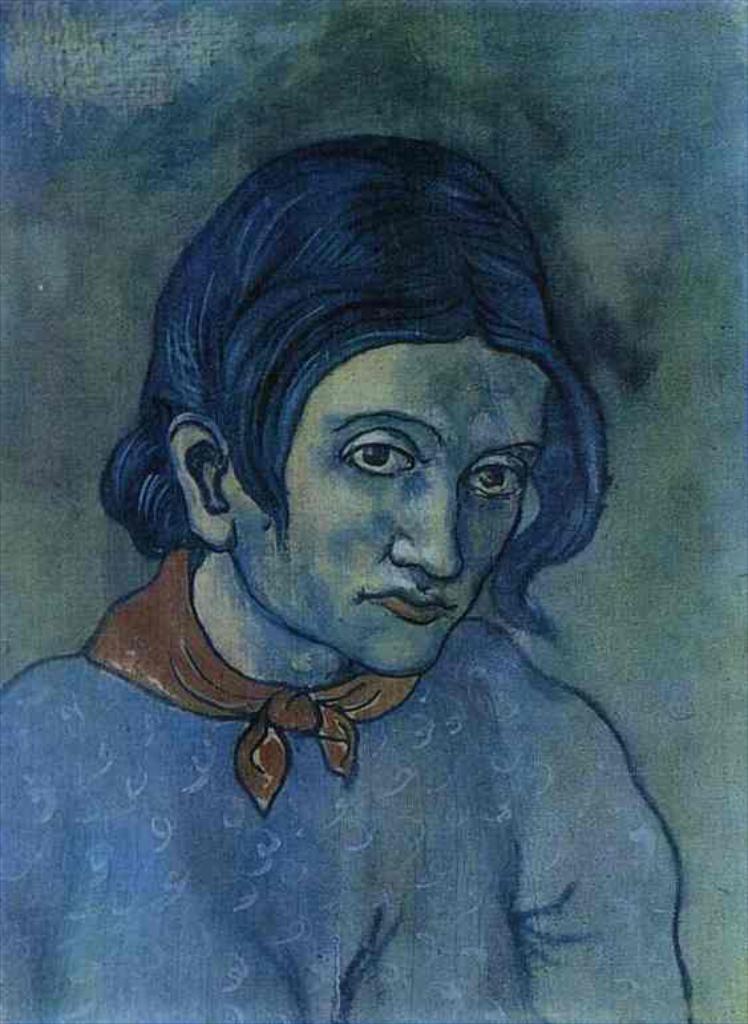How would you summarize this image in a sentence or two? In this image I can see an art of a person. I can also see scarf in orange color. 